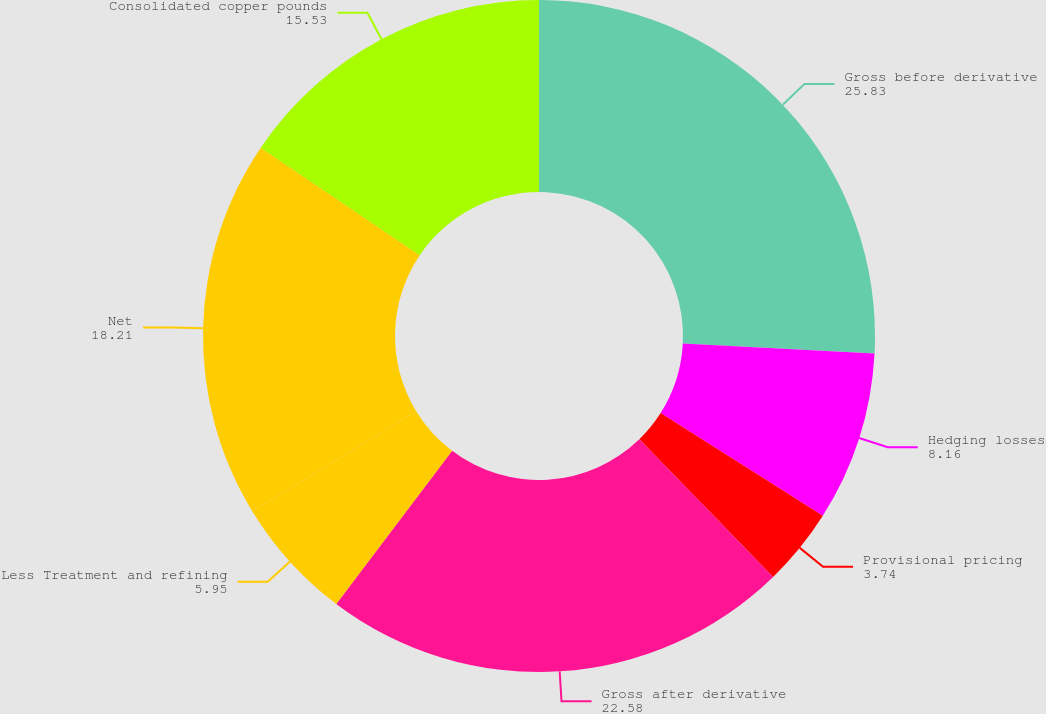Convert chart. <chart><loc_0><loc_0><loc_500><loc_500><pie_chart><fcel>Gross before derivative<fcel>Hedging losses<fcel>Provisional pricing<fcel>Gross after derivative<fcel>Less Treatment and refining<fcel>Net<fcel>Consolidated copper pounds<nl><fcel>25.83%<fcel>8.16%<fcel>3.74%<fcel>22.58%<fcel>5.95%<fcel>18.21%<fcel>15.53%<nl></chart> 